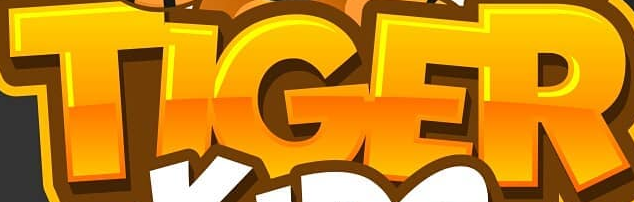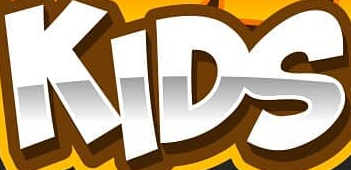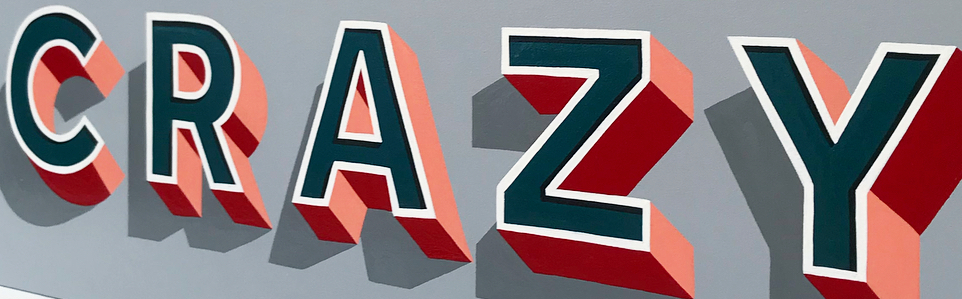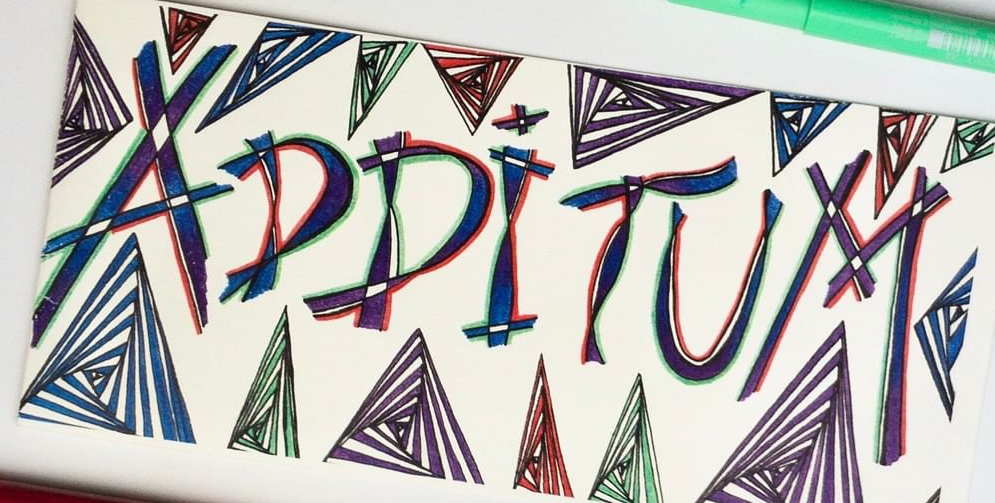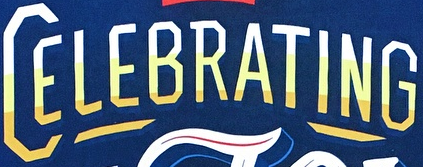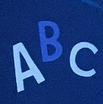What text is displayed in these images sequentially, separated by a semicolon? TIGER; KIDS; CRAZY; ADDITUM; CELEBRATING; ABC 